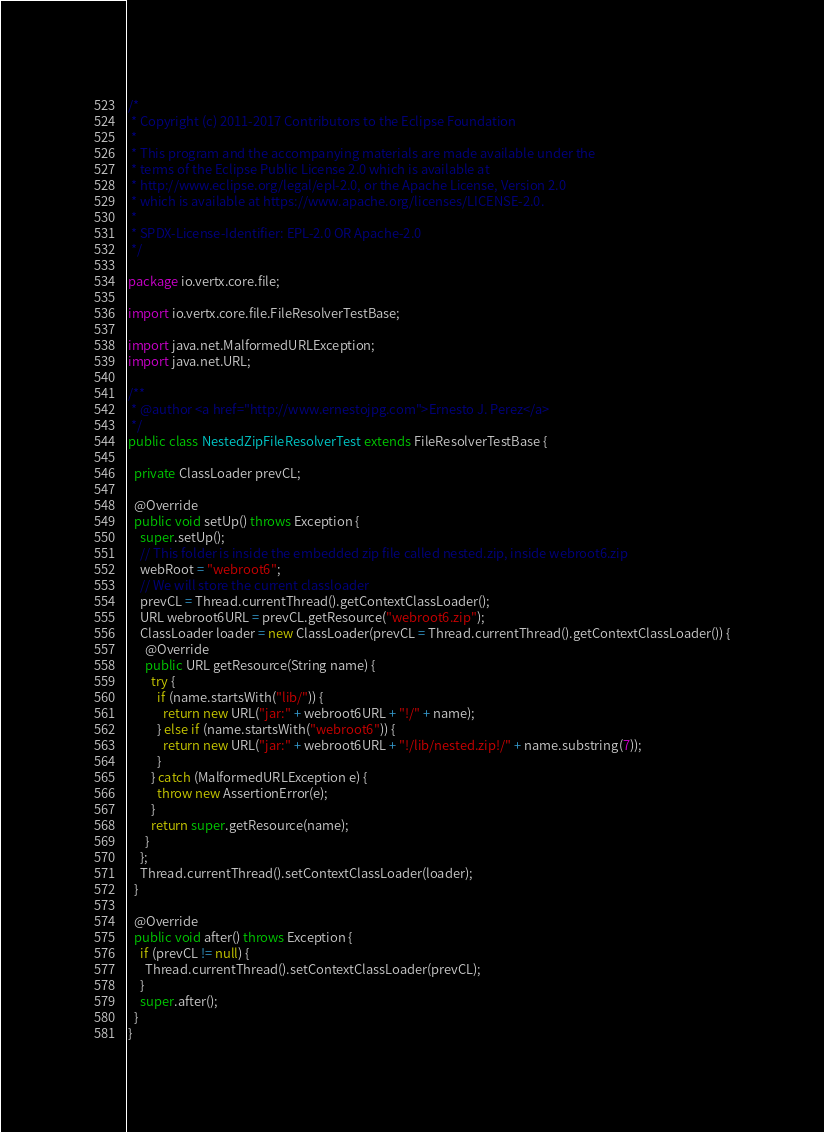Convert code to text. <code><loc_0><loc_0><loc_500><loc_500><_Java_>/*
 * Copyright (c) 2011-2017 Contributors to the Eclipse Foundation
 *
 * This program and the accompanying materials are made available under the
 * terms of the Eclipse Public License 2.0 which is available at
 * http://www.eclipse.org/legal/epl-2.0, or the Apache License, Version 2.0
 * which is available at https://www.apache.org/licenses/LICENSE-2.0.
 *
 * SPDX-License-Identifier: EPL-2.0 OR Apache-2.0
 */

package io.vertx.core.file;

import io.vertx.core.file.FileResolverTestBase;

import java.net.MalformedURLException;
import java.net.URL;

/**
 * @author <a href="http://www.ernestojpg.com">Ernesto J. Perez</a>
 */
public class NestedZipFileResolverTest extends FileResolverTestBase {

  private ClassLoader prevCL;

  @Override
  public void setUp() throws Exception {
    super.setUp();
    // This folder is inside the embedded zip file called nested.zip, inside webroot6.zip
    webRoot = "webroot6";
    // We will store the current classloader
    prevCL = Thread.currentThread().getContextClassLoader();
    URL webroot6URL = prevCL.getResource("webroot6.zip");
    ClassLoader loader = new ClassLoader(prevCL = Thread.currentThread().getContextClassLoader()) {
      @Override
      public URL getResource(String name) {
        try {
          if (name.startsWith("lib/")) {
            return new URL("jar:" + webroot6URL + "!/" + name);
          } else if (name.startsWith("webroot6")) {
            return new URL("jar:" + webroot6URL + "!/lib/nested.zip!/" + name.substring(7));
          }
        } catch (MalformedURLException e) {
          throw new AssertionError(e);
        }
        return super.getResource(name);
      }
    };
    Thread.currentThread().setContextClassLoader(loader);
  }

  @Override
  public void after() throws Exception {
    if (prevCL != null) {
      Thread.currentThread().setContextClassLoader(prevCL);
    }
    super.after();
  }
}
</code> 